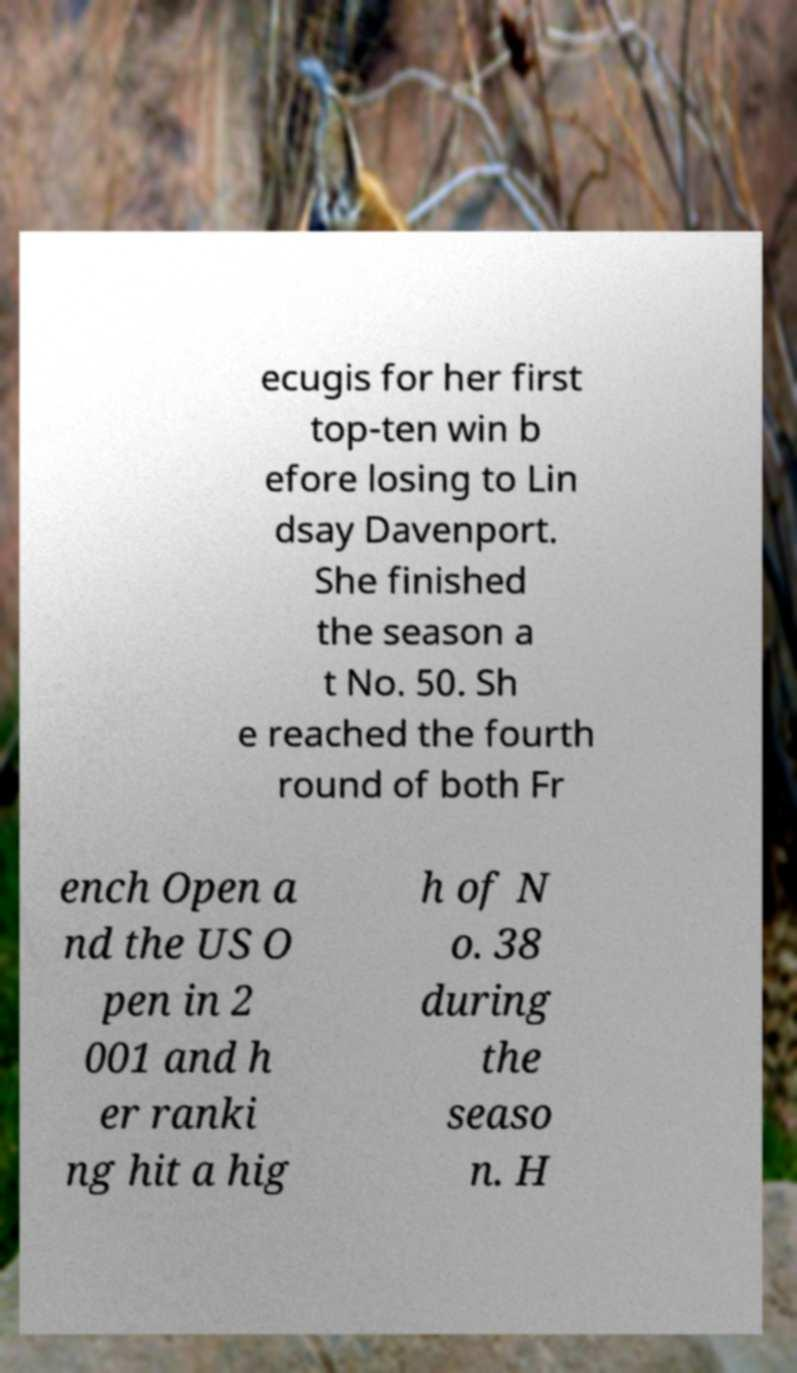I need the written content from this picture converted into text. Can you do that? ecugis for her first top-ten win b efore losing to Lin dsay Davenport. She finished the season a t No. 50. Sh e reached the fourth round of both Fr ench Open a nd the US O pen in 2 001 and h er ranki ng hit a hig h of N o. 38 during the seaso n. H 